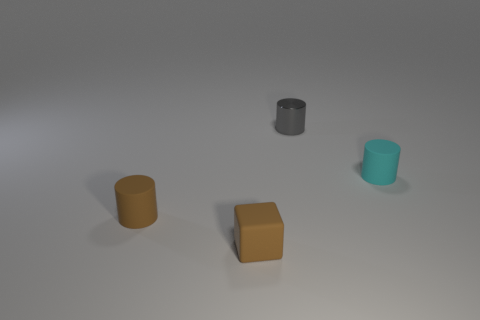Add 3 cyan objects. How many objects exist? 7 Subtract all blocks. How many objects are left? 3 Add 2 tiny cyan rubber cylinders. How many tiny cyan rubber cylinders are left? 3 Add 2 gray shiny cylinders. How many gray shiny cylinders exist? 3 Subtract 0 red blocks. How many objects are left? 4 Subtract all tiny shiny cylinders. Subtract all tiny cylinders. How many objects are left? 0 